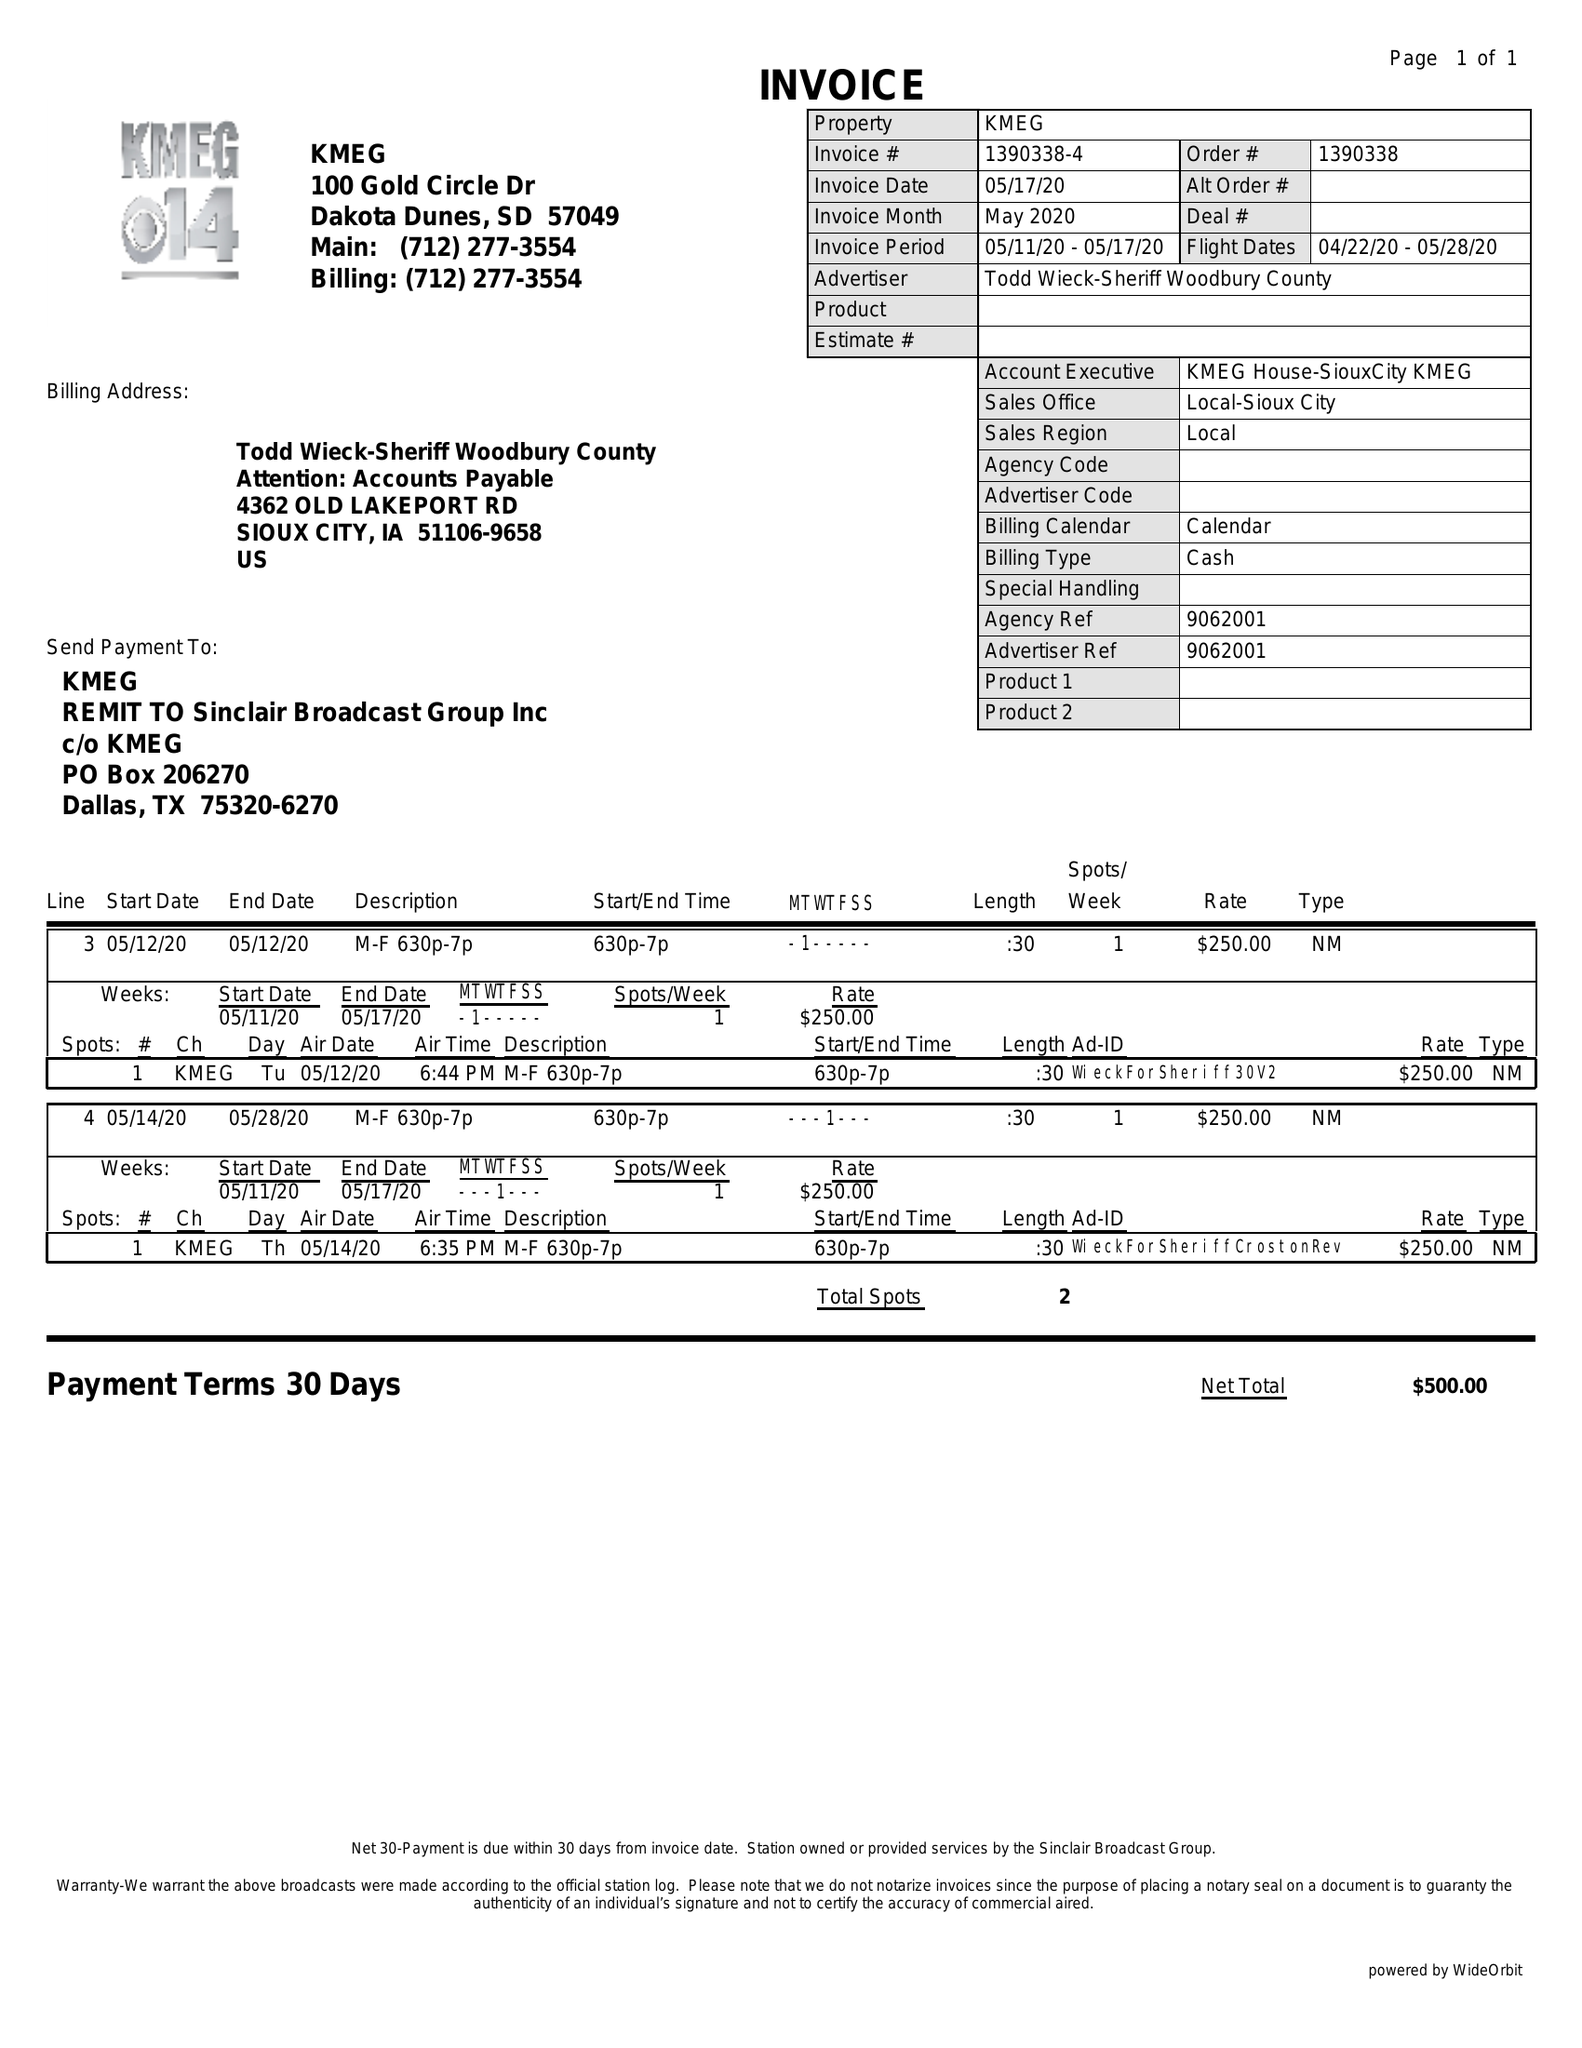What is the value for the flight_to?
Answer the question using a single word or phrase. 05/28/20 